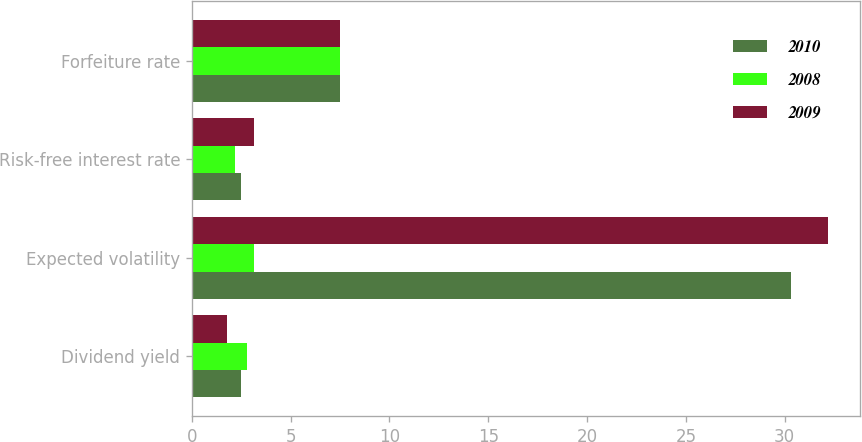<chart> <loc_0><loc_0><loc_500><loc_500><stacked_bar_chart><ecel><fcel>Dividend yield<fcel>Expected volatility<fcel>Risk-free interest rate<fcel>Forfeiture rate<nl><fcel>2010<fcel>2.5<fcel>30.3<fcel>2.5<fcel>7.5<nl><fcel>2008<fcel>2.8<fcel>3.15<fcel>2.2<fcel>7.5<nl><fcel>2009<fcel>1.8<fcel>32.2<fcel>3.15<fcel>7.5<nl></chart> 